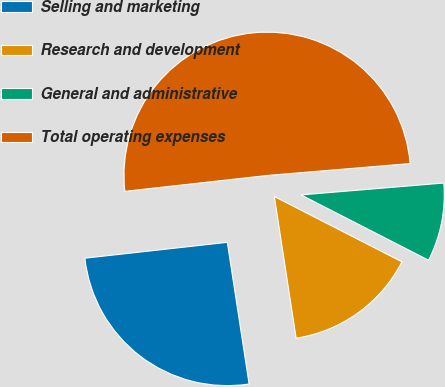Convert chart to OTSL. <chart><loc_0><loc_0><loc_500><loc_500><pie_chart><fcel>Selling and marketing<fcel>Research and development<fcel>General and administrative<fcel>Total operating expenses<nl><fcel>25.66%<fcel>15.04%<fcel>8.85%<fcel>50.44%<nl></chart> 